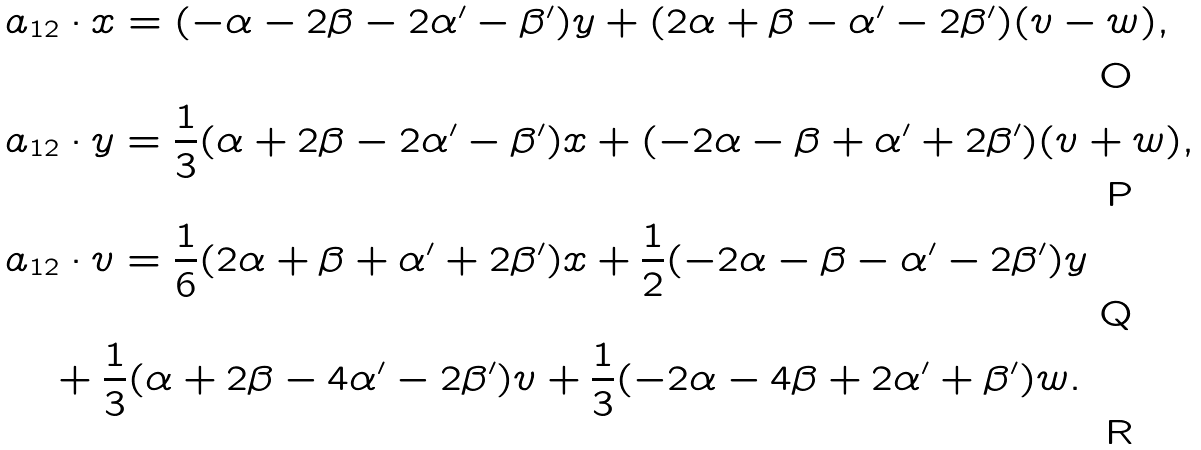<formula> <loc_0><loc_0><loc_500><loc_500>& a _ { 1 2 } \cdot x = ( - \alpha - 2 \beta - 2 \alpha ^ { \prime } - \beta ^ { \prime } ) y + ( 2 \alpha + \beta - \alpha ^ { \prime } - 2 \beta ^ { \prime } ) ( v - w ) , \\ & a _ { 1 2 } \cdot y = \frac { 1 } { 3 } ( \alpha + 2 \beta - 2 \alpha ^ { \prime } - \beta ^ { \prime } ) x + ( - 2 \alpha - \beta + \alpha ^ { \prime } + 2 \beta ^ { \prime } ) ( v + w ) , \\ & a _ { 1 2 } \cdot v = \frac { 1 } { 6 } ( 2 \alpha + \beta + \alpha ^ { \prime } + 2 \beta ^ { \prime } ) x + \frac { 1 } { 2 } ( - 2 \alpha - \beta - \alpha ^ { \prime } - 2 \beta ^ { \prime } ) y \\ & \quad + \frac { 1 } { 3 } ( \alpha + 2 \beta - 4 \alpha ^ { \prime } - 2 \beta ^ { \prime } ) v + \frac { 1 } { 3 } ( - 2 \alpha - 4 \beta + 2 \alpha ^ { \prime } + \beta ^ { \prime } ) w .</formula> 